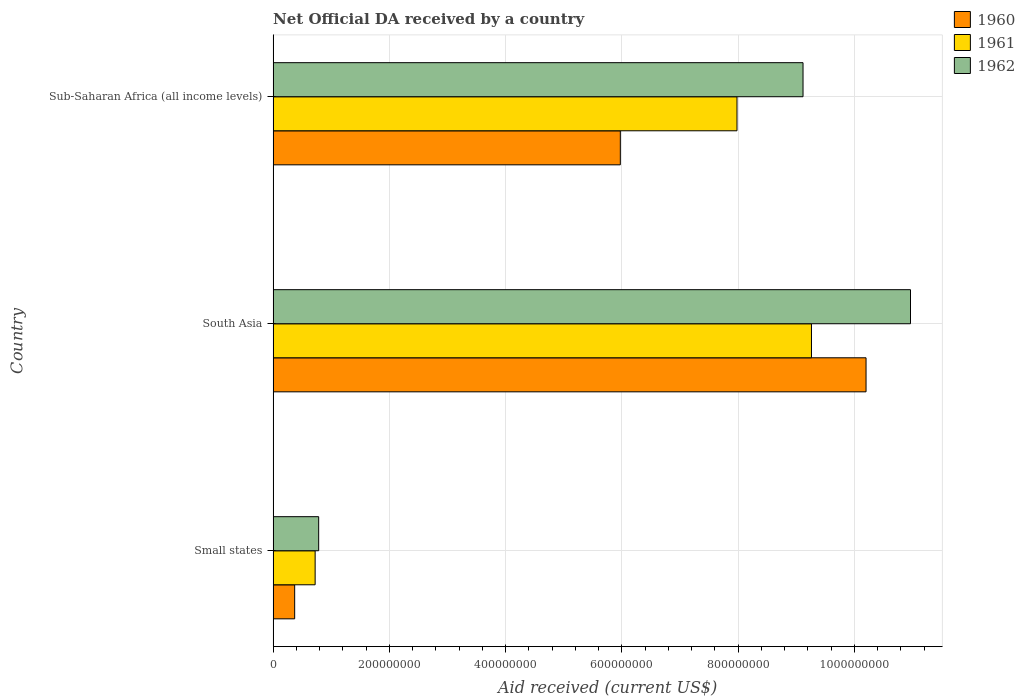How many different coloured bars are there?
Your answer should be compact. 3. Are the number of bars per tick equal to the number of legend labels?
Make the answer very short. Yes. Are the number of bars on each tick of the Y-axis equal?
Your answer should be compact. Yes. In how many cases, is the number of bars for a given country not equal to the number of legend labels?
Offer a terse response. 0. What is the net official development assistance aid received in 1961 in Small states?
Make the answer very short. 7.23e+07. Across all countries, what is the maximum net official development assistance aid received in 1962?
Ensure brevity in your answer.  1.10e+09. Across all countries, what is the minimum net official development assistance aid received in 1961?
Offer a very short reply. 7.23e+07. In which country was the net official development assistance aid received in 1960 minimum?
Provide a short and direct response. Small states. What is the total net official development assistance aid received in 1962 in the graph?
Offer a terse response. 2.09e+09. What is the difference between the net official development assistance aid received in 1960 in South Asia and that in Sub-Saharan Africa (all income levels)?
Provide a succinct answer. 4.23e+08. What is the difference between the net official development assistance aid received in 1960 in Sub-Saharan Africa (all income levels) and the net official development assistance aid received in 1961 in South Asia?
Your answer should be very brief. -3.29e+08. What is the average net official development assistance aid received in 1960 per country?
Keep it short and to the point. 5.52e+08. What is the difference between the net official development assistance aid received in 1962 and net official development assistance aid received in 1961 in Small states?
Provide a succinct answer. 6.09e+06. What is the ratio of the net official development assistance aid received in 1962 in Small states to that in South Asia?
Your answer should be very brief. 0.07. Is the net official development assistance aid received in 1962 in South Asia less than that in Sub-Saharan Africa (all income levels)?
Keep it short and to the point. No. Is the difference between the net official development assistance aid received in 1962 in South Asia and Sub-Saharan Africa (all income levels) greater than the difference between the net official development assistance aid received in 1961 in South Asia and Sub-Saharan Africa (all income levels)?
Give a very brief answer. Yes. What is the difference between the highest and the second highest net official development assistance aid received in 1962?
Provide a short and direct response. 1.85e+08. What is the difference between the highest and the lowest net official development assistance aid received in 1961?
Make the answer very short. 8.54e+08. In how many countries, is the net official development assistance aid received in 1962 greater than the average net official development assistance aid received in 1962 taken over all countries?
Make the answer very short. 2. What does the 1st bar from the top in Sub-Saharan Africa (all income levels) represents?
Provide a succinct answer. 1962. What does the 3rd bar from the bottom in South Asia represents?
Provide a succinct answer. 1962. Is it the case that in every country, the sum of the net official development assistance aid received in 1960 and net official development assistance aid received in 1961 is greater than the net official development assistance aid received in 1962?
Keep it short and to the point. Yes. How many bars are there?
Your response must be concise. 9. Are all the bars in the graph horizontal?
Offer a very short reply. Yes. What is the difference between two consecutive major ticks on the X-axis?
Make the answer very short. 2.00e+08. Does the graph contain any zero values?
Your answer should be very brief. No. Where does the legend appear in the graph?
Your response must be concise. Top right. How are the legend labels stacked?
Your response must be concise. Vertical. What is the title of the graph?
Your answer should be compact. Net Official DA received by a country. Does "1996" appear as one of the legend labels in the graph?
Keep it short and to the point. No. What is the label or title of the X-axis?
Provide a short and direct response. Aid received (current US$). What is the Aid received (current US$) in 1960 in Small states?
Provide a short and direct response. 3.71e+07. What is the Aid received (current US$) in 1961 in Small states?
Provide a succinct answer. 7.23e+07. What is the Aid received (current US$) of 1962 in Small states?
Make the answer very short. 7.84e+07. What is the Aid received (current US$) in 1960 in South Asia?
Your answer should be compact. 1.02e+09. What is the Aid received (current US$) of 1961 in South Asia?
Keep it short and to the point. 9.26e+08. What is the Aid received (current US$) in 1962 in South Asia?
Provide a short and direct response. 1.10e+09. What is the Aid received (current US$) in 1960 in Sub-Saharan Africa (all income levels)?
Ensure brevity in your answer.  5.97e+08. What is the Aid received (current US$) of 1961 in Sub-Saharan Africa (all income levels)?
Provide a short and direct response. 7.98e+08. What is the Aid received (current US$) in 1962 in Sub-Saharan Africa (all income levels)?
Your answer should be very brief. 9.12e+08. Across all countries, what is the maximum Aid received (current US$) in 1960?
Ensure brevity in your answer.  1.02e+09. Across all countries, what is the maximum Aid received (current US$) in 1961?
Provide a succinct answer. 9.26e+08. Across all countries, what is the maximum Aid received (current US$) of 1962?
Keep it short and to the point. 1.10e+09. Across all countries, what is the minimum Aid received (current US$) in 1960?
Your answer should be compact. 3.71e+07. Across all countries, what is the minimum Aid received (current US$) in 1961?
Make the answer very short. 7.23e+07. Across all countries, what is the minimum Aid received (current US$) in 1962?
Your response must be concise. 7.84e+07. What is the total Aid received (current US$) of 1960 in the graph?
Provide a succinct answer. 1.65e+09. What is the total Aid received (current US$) of 1961 in the graph?
Offer a very short reply. 1.80e+09. What is the total Aid received (current US$) of 1962 in the graph?
Provide a succinct answer. 2.09e+09. What is the difference between the Aid received (current US$) of 1960 in Small states and that in South Asia?
Your answer should be very brief. -9.83e+08. What is the difference between the Aid received (current US$) in 1961 in Small states and that in South Asia?
Your answer should be compact. -8.54e+08. What is the difference between the Aid received (current US$) of 1962 in Small states and that in South Asia?
Offer a very short reply. -1.02e+09. What is the difference between the Aid received (current US$) of 1960 in Small states and that in Sub-Saharan Africa (all income levels)?
Provide a succinct answer. -5.60e+08. What is the difference between the Aid received (current US$) in 1961 in Small states and that in Sub-Saharan Africa (all income levels)?
Provide a short and direct response. -7.26e+08. What is the difference between the Aid received (current US$) of 1962 in Small states and that in Sub-Saharan Africa (all income levels)?
Ensure brevity in your answer.  -8.33e+08. What is the difference between the Aid received (current US$) in 1960 in South Asia and that in Sub-Saharan Africa (all income levels)?
Keep it short and to the point. 4.23e+08. What is the difference between the Aid received (current US$) in 1961 in South Asia and that in Sub-Saharan Africa (all income levels)?
Keep it short and to the point. 1.28e+08. What is the difference between the Aid received (current US$) of 1962 in South Asia and that in Sub-Saharan Africa (all income levels)?
Your response must be concise. 1.85e+08. What is the difference between the Aid received (current US$) in 1960 in Small states and the Aid received (current US$) in 1961 in South Asia?
Give a very brief answer. -8.89e+08. What is the difference between the Aid received (current US$) of 1960 in Small states and the Aid received (current US$) of 1962 in South Asia?
Your answer should be very brief. -1.06e+09. What is the difference between the Aid received (current US$) in 1961 in Small states and the Aid received (current US$) in 1962 in South Asia?
Make the answer very short. -1.02e+09. What is the difference between the Aid received (current US$) of 1960 in Small states and the Aid received (current US$) of 1961 in Sub-Saharan Africa (all income levels)?
Offer a terse response. -7.61e+08. What is the difference between the Aid received (current US$) in 1960 in Small states and the Aid received (current US$) in 1962 in Sub-Saharan Africa (all income levels)?
Your response must be concise. -8.75e+08. What is the difference between the Aid received (current US$) in 1961 in Small states and the Aid received (current US$) in 1962 in Sub-Saharan Africa (all income levels)?
Offer a terse response. -8.39e+08. What is the difference between the Aid received (current US$) of 1960 in South Asia and the Aid received (current US$) of 1961 in Sub-Saharan Africa (all income levels)?
Provide a succinct answer. 2.22e+08. What is the difference between the Aid received (current US$) in 1960 in South Asia and the Aid received (current US$) in 1962 in Sub-Saharan Africa (all income levels)?
Give a very brief answer. 1.08e+08. What is the difference between the Aid received (current US$) of 1961 in South Asia and the Aid received (current US$) of 1962 in Sub-Saharan Africa (all income levels)?
Offer a very short reply. 1.45e+07. What is the average Aid received (current US$) of 1960 per country?
Provide a short and direct response. 5.52e+08. What is the average Aid received (current US$) in 1961 per country?
Provide a short and direct response. 5.99e+08. What is the average Aid received (current US$) of 1962 per country?
Your response must be concise. 6.96e+08. What is the difference between the Aid received (current US$) in 1960 and Aid received (current US$) in 1961 in Small states?
Make the answer very short. -3.52e+07. What is the difference between the Aid received (current US$) of 1960 and Aid received (current US$) of 1962 in Small states?
Provide a short and direct response. -4.13e+07. What is the difference between the Aid received (current US$) in 1961 and Aid received (current US$) in 1962 in Small states?
Provide a short and direct response. -6.09e+06. What is the difference between the Aid received (current US$) in 1960 and Aid received (current US$) in 1961 in South Asia?
Ensure brevity in your answer.  9.39e+07. What is the difference between the Aid received (current US$) of 1960 and Aid received (current US$) of 1962 in South Asia?
Your answer should be very brief. -7.65e+07. What is the difference between the Aid received (current US$) of 1961 and Aid received (current US$) of 1962 in South Asia?
Your answer should be very brief. -1.70e+08. What is the difference between the Aid received (current US$) of 1960 and Aid received (current US$) of 1961 in Sub-Saharan Africa (all income levels)?
Provide a short and direct response. -2.01e+08. What is the difference between the Aid received (current US$) in 1960 and Aid received (current US$) in 1962 in Sub-Saharan Africa (all income levels)?
Give a very brief answer. -3.14e+08. What is the difference between the Aid received (current US$) in 1961 and Aid received (current US$) in 1962 in Sub-Saharan Africa (all income levels)?
Offer a terse response. -1.14e+08. What is the ratio of the Aid received (current US$) in 1960 in Small states to that in South Asia?
Ensure brevity in your answer.  0.04. What is the ratio of the Aid received (current US$) in 1961 in Small states to that in South Asia?
Keep it short and to the point. 0.08. What is the ratio of the Aid received (current US$) of 1962 in Small states to that in South Asia?
Provide a short and direct response. 0.07. What is the ratio of the Aid received (current US$) of 1960 in Small states to that in Sub-Saharan Africa (all income levels)?
Ensure brevity in your answer.  0.06. What is the ratio of the Aid received (current US$) in 1961 in Small states to that in Sub-Saharan Africa (all income levels)?
Your answer should be very brief. 0.09. What is the ratio of the Aid received (current US$) in 1962 in Small states to that in Sub-Saharan Africa (all income levels)?
Keep it short and to the point. 0.09. What is the ratio of the Aid received (current US$) in 1960 in South Asia to that in Sub-Saharan Africa (all income levels)?
Your answer should be compact. 1.71. What is the ratio of the Aid received (current US$) of 1961 in South Asia to that in Sub-Saharan Africa (all income levels)?
Give a very brief answer. 1.16. What is the ratio of the Aid received (current US$) of 1962 in South Asia to that in Sub-Saharan Africa (all income levels)?
Your response must be concise. 1.2. What is the difference between the highest and the second highest Aid received (current US$) in 1960?
Offer a terse response. 4.23e+08. What is the difference between the highest and the second highest Aid received (current US$) of 1961?
Provide a succinct answer. 1.28e+08. What is the difference between the highest and the second highest Aid received (current US$) in 1962?
Your answer should be compact. 1.85e+08. What is the difference between the highest and the lowest Aid received (current US$) of 1960?
Provide a short and direct response. 9.83e+08. What is the difference between the highest and the lowest Aid received (current US$) of 1961?
Offer a very short reply. 8.54e+08. What is the difference between the highest and the lowest Aid received (current US$) in 1962?
Give a very brief answer. 1.02e+09. 